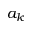<formula> <loc_0><loc_0><loc_500><loc_500>a _ { k }</formula> 